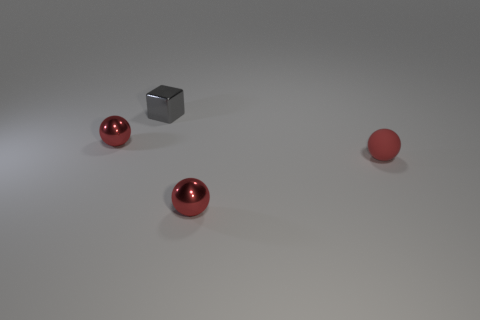Add 1 small rubber things. How many objects exist? 5 Subtract all spheres. How many objects are left? 1 Subtract all balls. Subtract all tiny gray shiny objects. How many objects are left? 0 Add 3 tiny red things. How many tiny red things are left? 6 Add 1 large green metal cylinders. How many large green metal cylinders exist? 1 Subtract 0 brown cylinders. How many objects are left? 4 